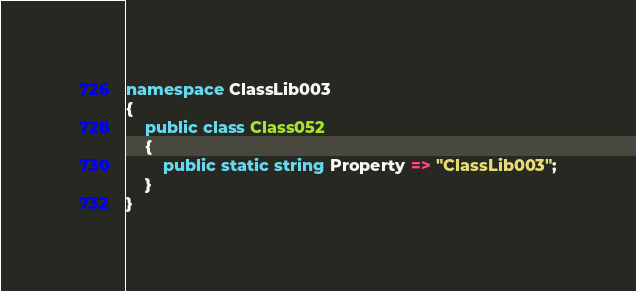Convert code to text. <code><loc_0><loc_0><loc_500><loc_500><_C#_>namespace ClassLib003
{
    public class Class052
    {
        public static string Property => "ClassLib003";
    }
}
</code> 